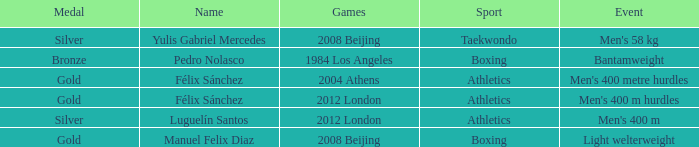What Medal had a Name of manuel felix diaz? Gold. 